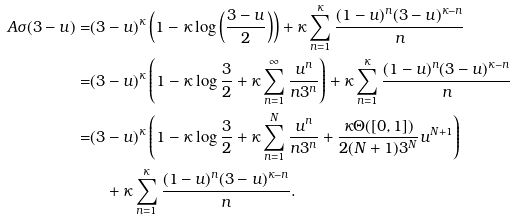<formula> <loc_0><loc_0><loc_500><loc_500>A \sigma ( 3 - u ) = & ( 3 - u ) ^ { \kappa } \left ( 1 - \kappa \log \left ( \frac { 3 - u } 2 \right ) \right ) + \kappa \sum _ { n = 1 } ^ { \kappa } \frac { ( 1 - u ) ^ { n } ( 3 - u ) ^ { \kappa - n } } { n } \\ = & ( 3 - u ) ^ { \kappa } \left ( 1 - \kappa \log \frac { 3 } { 2 } + \kappa \sum _ { n = 1 } ^ { \infty } \frac { u ^ { n } } { n 3 ^ { n } } \right ) + \kappa \sum _ { n = 1 } ^ { \kappa } \frac { ( 1 - u ) ^ { n } ( 3 - u ) ^ { \kappa - n } } { n } \\ = & ( 3 - u ) ^ { \kappa } \left ( 1 - \kappa \log \frac { 3 } { 2 } + \kappa \sum _ { n = 1 } ^ { N } \frac { u ^ { n } } { n 3 ^ { n } } + \frac { \kappa \Theta ( [ 0 , 1 ] ) } { 2 ( N + 1 ) 3 ^ { N } } u ^ { N + 1 } \right ) \\ & \quad + \kappa \sum _ { n = 1 } ^ { \kappa } \frac { ( 1 - u ) ^ { n } ( 3 - u ) ^ { \kappa - n } } { n } .</formula> 